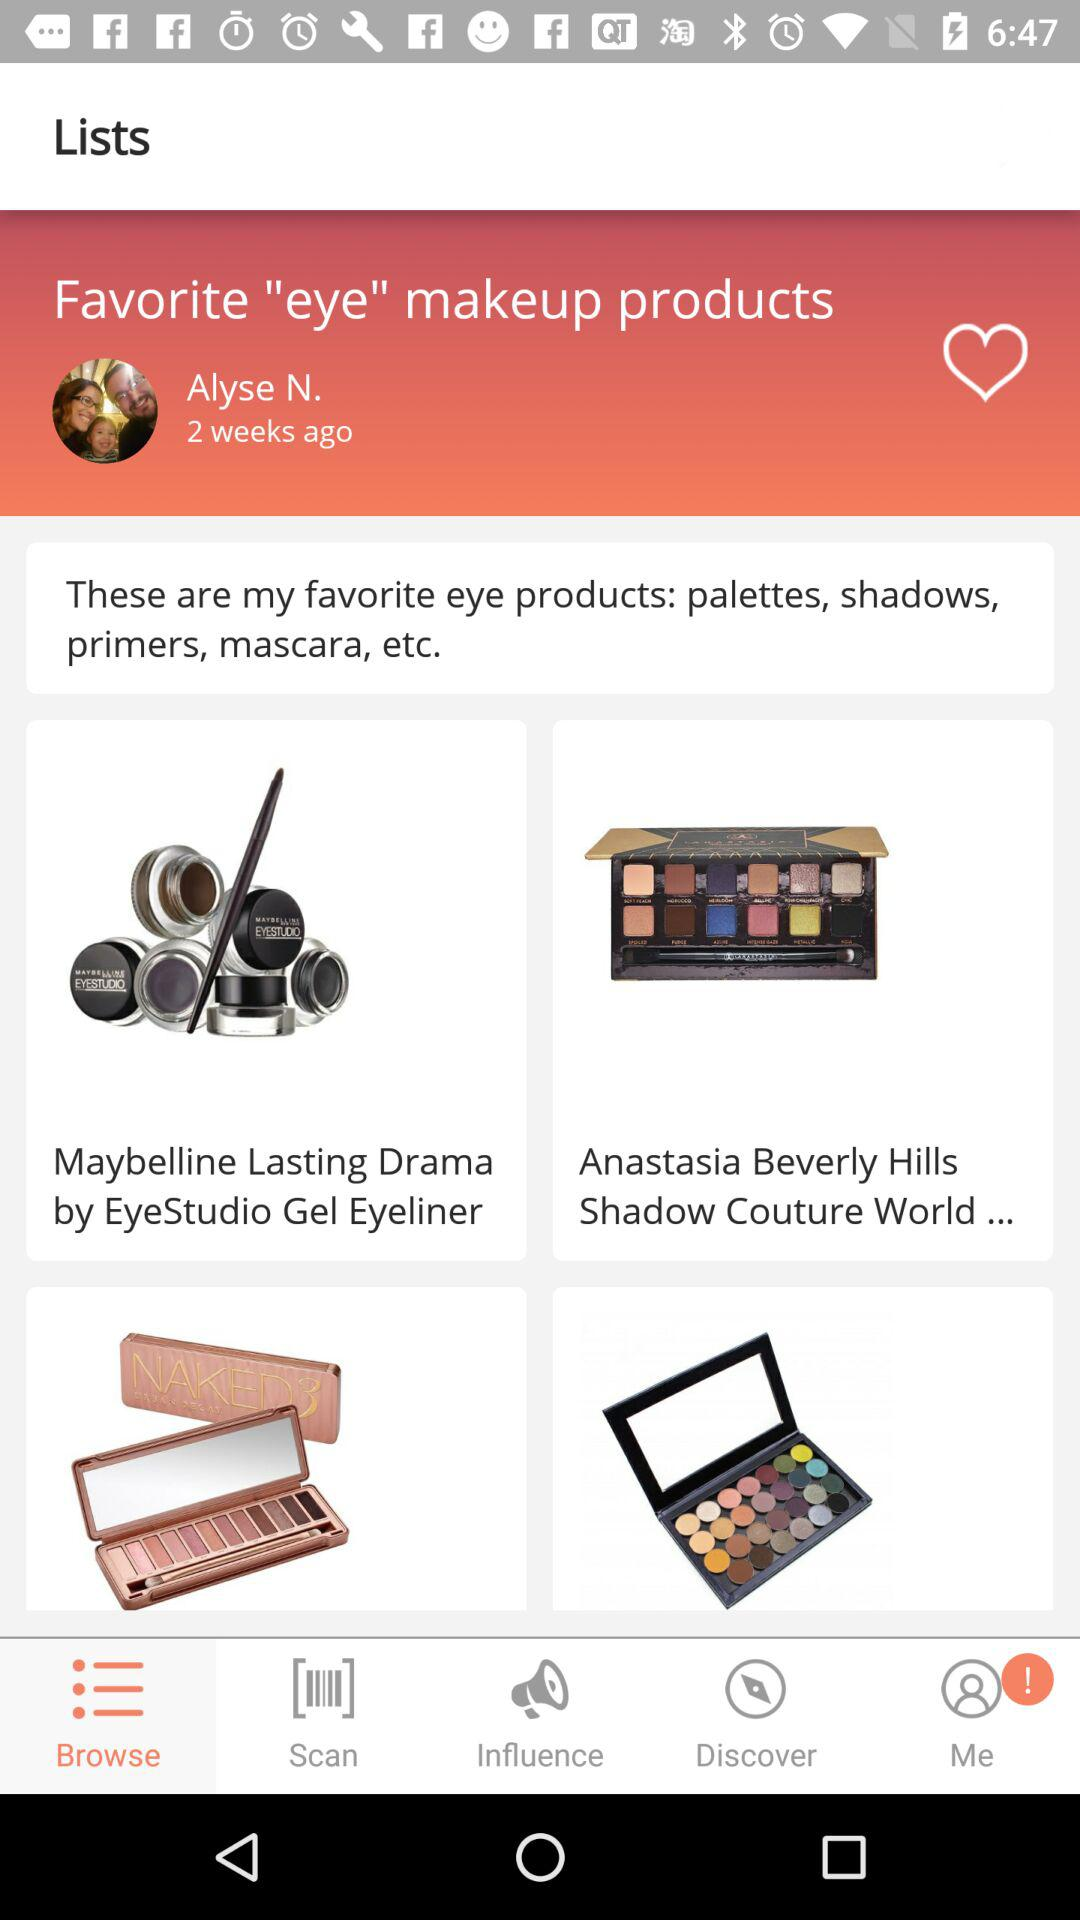What's the user profile name? The user profile name is Alyse N. 